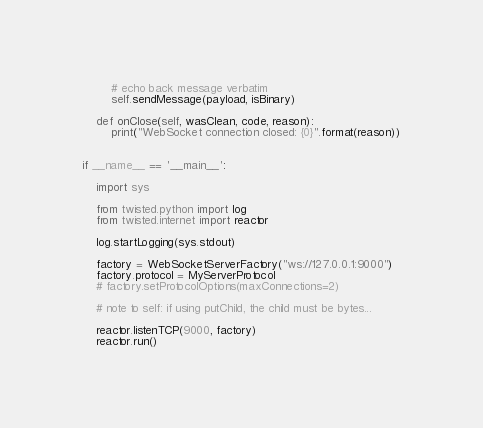<code> <loc_0><loc_0><loc_500><loc_500><_Python_>
        # echo back message verbatim
        self.sendMessage(payload, isBinary)

    def onClose(self, wasClean, code, reason):
        print("WebSocket connection closed: {0}".format(reason))


if __name__ == '__main__':

    import sys

    from twisted.python import log
    from twisted.internet import reactor

    log.startLogging(sys.stdout)

    factory = WebSocketServerFactory("ws://127.0.0.1:9000")
    factory.protocol = MyServerProtocol
    # factory.setProtocolOptions(maxConnections=2)

    # note to self: if using putChild, the child must be bytes...

    reactor.listenTCP(9000, factory)
    reactor.run()
</code> 